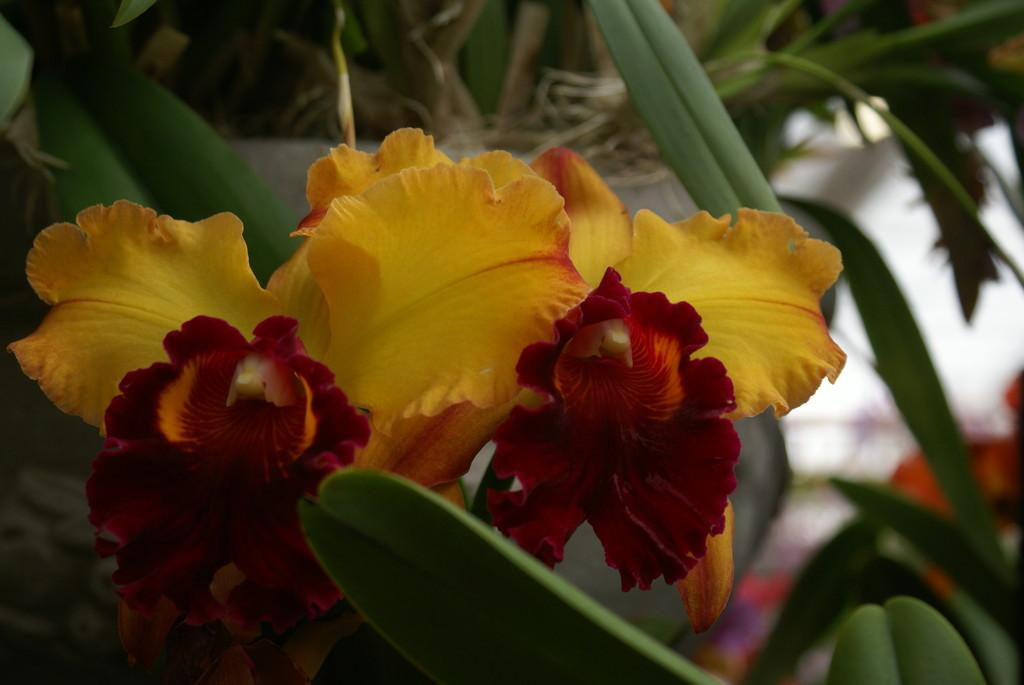What type of living organisms can be seen in the image? There are flowers and plants in the image. Can you describe the plants in the image? The plants in the image are not specified, but they are present alongside the flowers. How many chairs are visible in the image? There are no chairs present in the image; it features flowers and plants. What type of view can be seen from the image? The image does not depict a view, as it focuses on flowers and plants. 